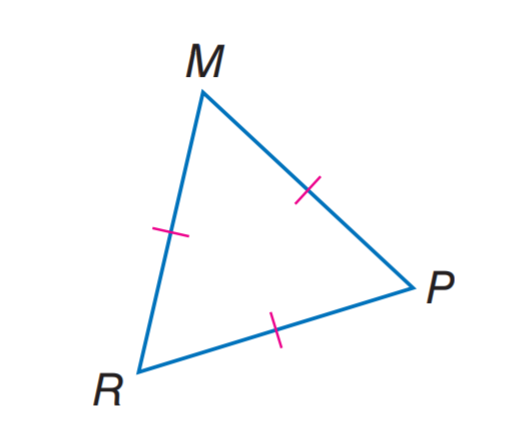Question: Find m \angle M R P.
Choices:
A. 40
B. 50
C. 60
D. 80
Answer with the letter. Answer: C 